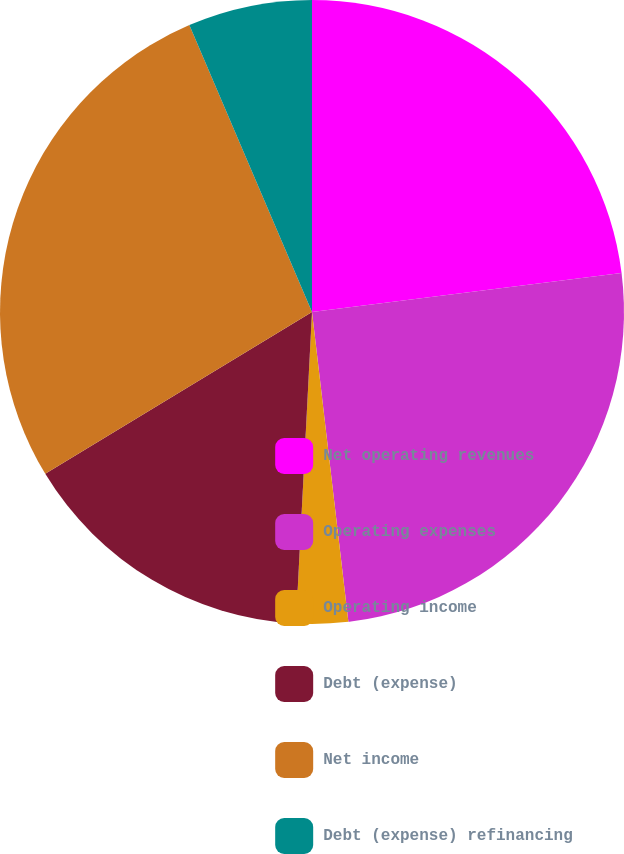<chart> <loc_0><loc_0><loc_500><loc_500><pie_chart><fcel>Net operating revenues<fcel>Operating expenses<fcel>Operating income<fcel>Debt (expense)<fcel>Net income<fcel>Debt (expense) refinancing<nl><fcel>23.01%<fcel>25.13%<fcel>2.68%<fcel>15.5%<fcel>27.25%<fcel>6.43%<nl></chart> 